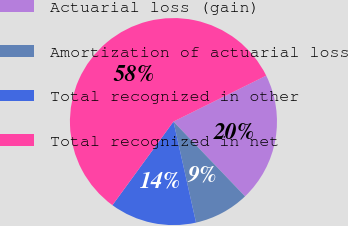Convert chart. <chart><loc_0><loc_0><loc_500><loc_500><pie_chart><fcel>Actuarial loss (gain)<fcel>Amortization of actuarial loss<fcel>Total recognized in other<fcel>Total recognized in net<nl><fcel>20.17%<fcel>8.65%<fcel>13.54%<fcel>57.64%<nl></chart> 